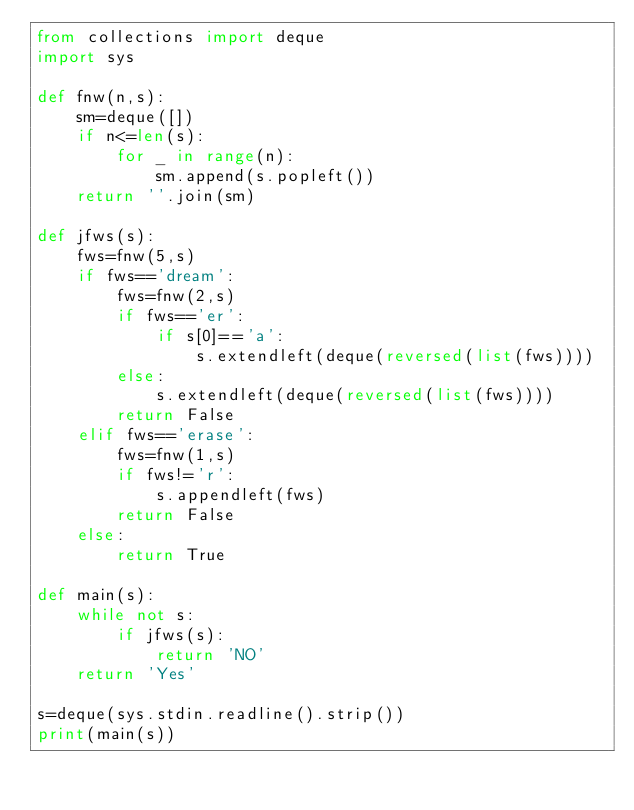<code> <loc_0><loc_0><loc_500><loc_500><_Python_>from collections import deque
import sys

def fnw(n,s):
    sm=deque([])
    if n<=len(s):
        for _ in range(n):
            sm.append(s.popleft())
    return ''.join(sm)

def jfws(s):
    fws=fnw(5,s)
    if fws=='dream':
        fws=fnw(2,s)
        if fws=='er':
            if s[0]=='a':
                s.extendleft(deque(reversed(list(fws))))
        else:
            s.extendleft(deque(reversed(list(fws))))
        return False
    elif fws=='erase':
        fws=fnw(1,s)
        if fws!='r':
            s.appendleft(fws)
        return False
    else:
        return True 

def main(s):
    while not s:
        if jfws(s):
            return 'NO'
    return 'Yes'

s=deque(sys.stdin.readline().strip())
print(main(s))

</code> 